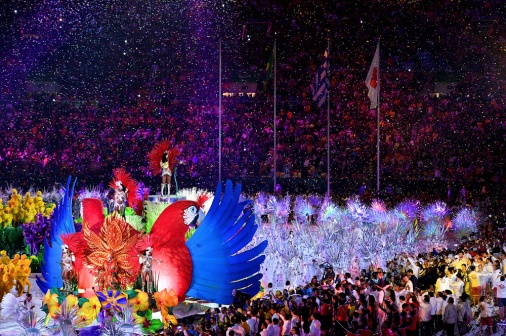What are the key elements in this picture?
 The image captures a lively parade taking place in a stadium filled with spectators. The parade is characterized by participants in vibrant costumes, their colors popping against the backdrop of the crowd. 

The central focus of the image is on two large bird-like structures, one bathed in a fiery red and the other in a cool blue. The red bird, positioned to the left, has a person standing atop it, giving the impression of riding the creature. On the other hand, the blue bird, located to the right, has a person sitting on top, seemingly guiding the creature through the crowd.

The parade, including these bird structures, is moving towards the right side of the image, creating a sense of motion and energy. The background is a sea of people, their faces a blur of excitement and anticipation. Confetti dots the air, adding to the festive atmosphere.

Scattered throughout the image are flags and poles, possibly carried by the parade participants or spectators, further enhancing the celebratory mood. The precise locations of these objects vary, but they appear throughout the crowd and parade.

The image does not contain any discernible text. The relative positions of the objects, particularly the bird structures, suggest a coordinated movement, possibly a choreographed performance for the spectators. The image exudes a sense of joy, celebration, and community spirit. 